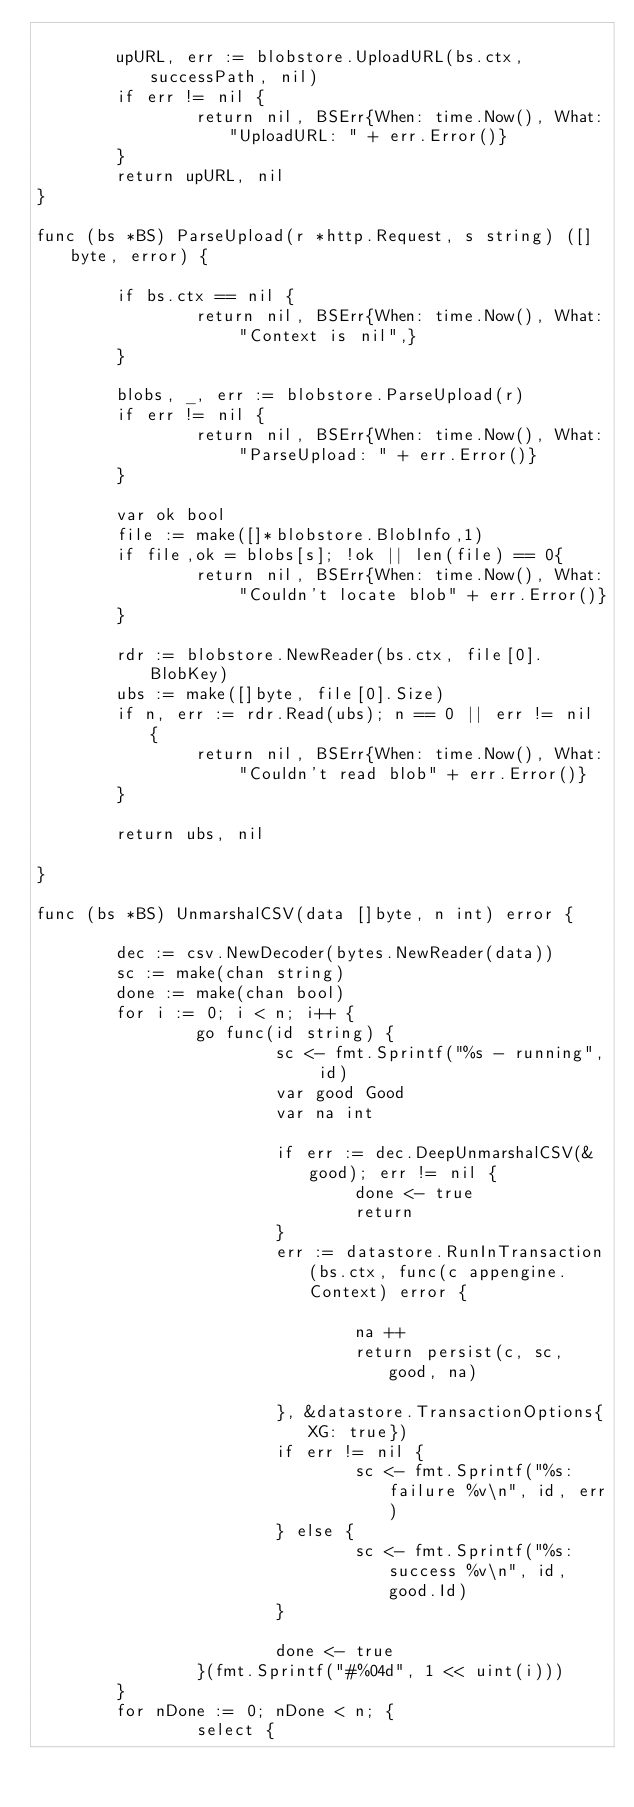<code> <loc_0><loc_0><loc_500><loc_500><_Go_>
        upURL, err := blobstore.UploadURL(bs.ctx, successPath, nil)
        if err != nil {
                return nil, BSErr{When: time.Now(), What:"UploadURL: " + err.Error()}
        }
        return upURL, nil
}

func (bs *BS) ParseUpload(r *http.Request, s string) ([]byte, error) {

        if bs.ctx == nil {
                return nil, BSErr{When: time.Now(), What: "Context is nil",}
        }

        blobs, _, err := blobstore.ParseUpload(r)
        if err != nil {
                return nil, BSErr{When: time.Now(), What: "ParseUpload: " + err.Error()}
        }

        var ok bool
        file := make([]*blobstore.BlobInfo,1)
        if file,ok = blobs[s]; !ok || len(file) == 0{
                return nil, BSErr{When: time.Now(), What: "Couldn't locate blob" + err.Error()}
        }

        rdr := blobstore.NewReader(bs.ctx, file[0].BlobKey)
        ubs := make([]byte, file[0].Size)
        if n, err := rdr.Read(ubs); n == 0 || err != nil {
                return nil, BSErr{When: time.Now(), What: "Couldn't read blob" + err.Error()}
        }

        return ubs, nil

}

func (bs *BS) UnmarshalCSV(data []byte, n int) error {

        dec := csv.NewDecoder(bytes.NewReader(data))
        sc := make(chan string)
        done := make(chan bool)
        for i := 0; i < n; i++ {
                go func(id string) {
                        sc <- fmt.Sprintf("%s - running", id)
                        var good Good
                        var na int

                        if err := dec.DeepUnmarshalCSV(&good); err != nil {
                                done <- true
                                return
                        }
                        err := datastore.RunInTransaction(bs.ctx, func(c appengine.Context) error {

                                na ++
                                return persist(c, sc, good, na)

                        }, &datastore.TransactionOptions{XG: true})
                        if err != nil {
                                sc <- fmt.Sprintf("%s: failure %v\n", id, err)
                        } else {
                                sc <- fmt.Sprintf("%s: success %v\n", id, good.Id)
                        }

                        done <- true
                }(fmt.Sprintf("#%04d", 1 << uint(i)))
        }
        for nDone := 0; nDone < n; {
                select {</code> 